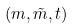Convert formula to latex. <formula><loc_0><loc_0><loc_500><loc_500>( m , \tilde { m } , t )</formula> 